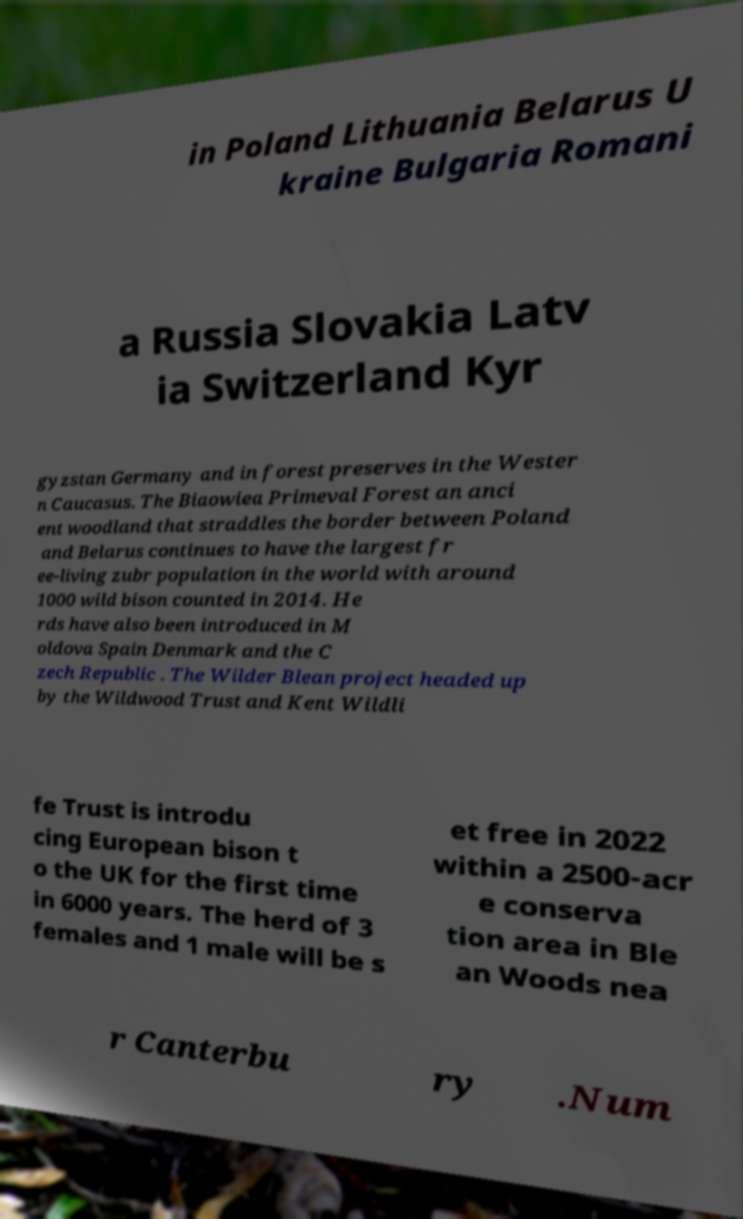Please read and relay the text visible in this image. What does it say? in Poland Lithuania Belarus U kraine Bulgaria Romani a Russia Slovakia Latv ia Switzerland Kyr gyzstan Germany and in forest preserves in the Wester n Caucasus. The Biaowiea Primeval Forest an anci ent woodland that straddles the border between Poland and Belarus continues to have the largest fr ee-living zubr population in the world with around 1000 wild bison counted in 2014. He rds have also been introduced in M oldova Spain Denmark and the C zech Republic . The Wilder Blean project headed up by the Wildwood Trust and Kent Wildli fe Trust is introdu cing European bison t o the UK for the first time in 6000 years. The herd of 3 females and 1 male will be s et free in 2022 within a 2500-acr e conserva tion area in Ble an Woods nea r Canterbu ry .Num 